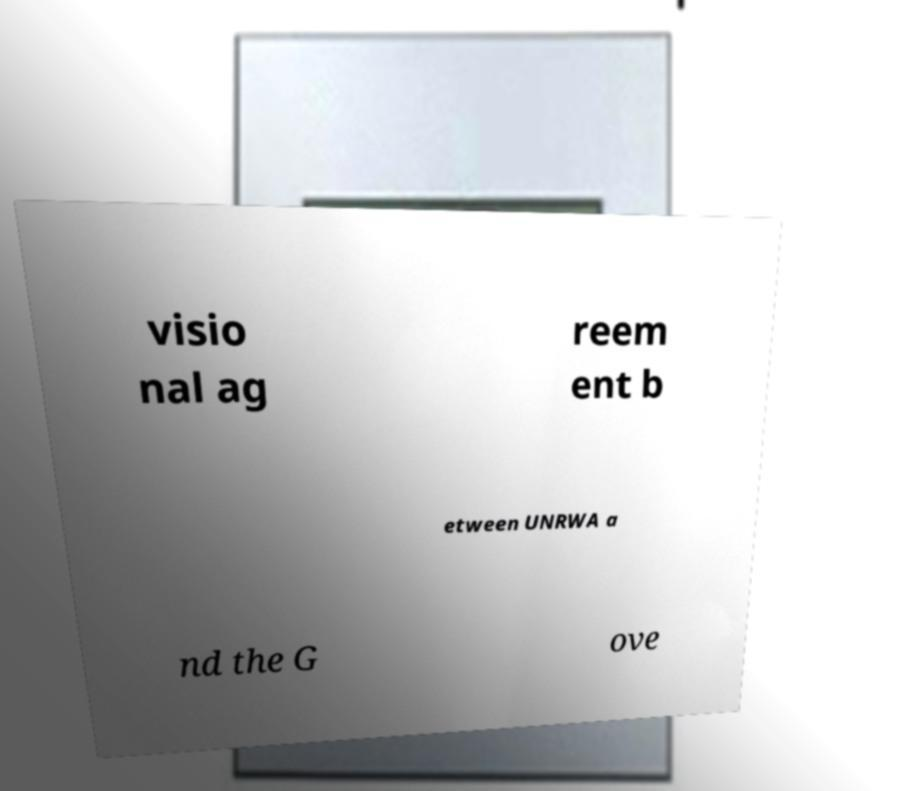There's text embedded in this image that I need extracted. Can you transcribe it verbatim? visio nal ag reem ent b etween UNRWA a nd the G ove 